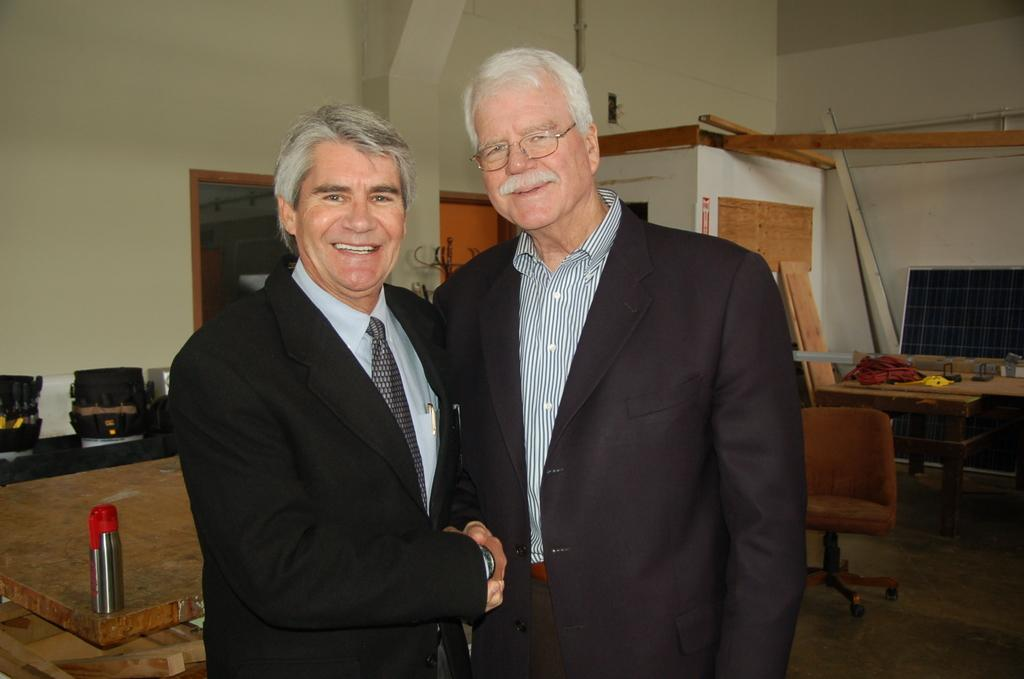How many people are in the image? There are two old men in the image. What are the old men doing in the image? The old men are shaking hands. What electronic device is present in the image? There is a monitor in the image. What type of furniture is in the image? There is a table and a chair in the image. What type of club is the old men attending in the image? There is no indication of a club or any event in the image; it simply shows two old men shaking hands. 